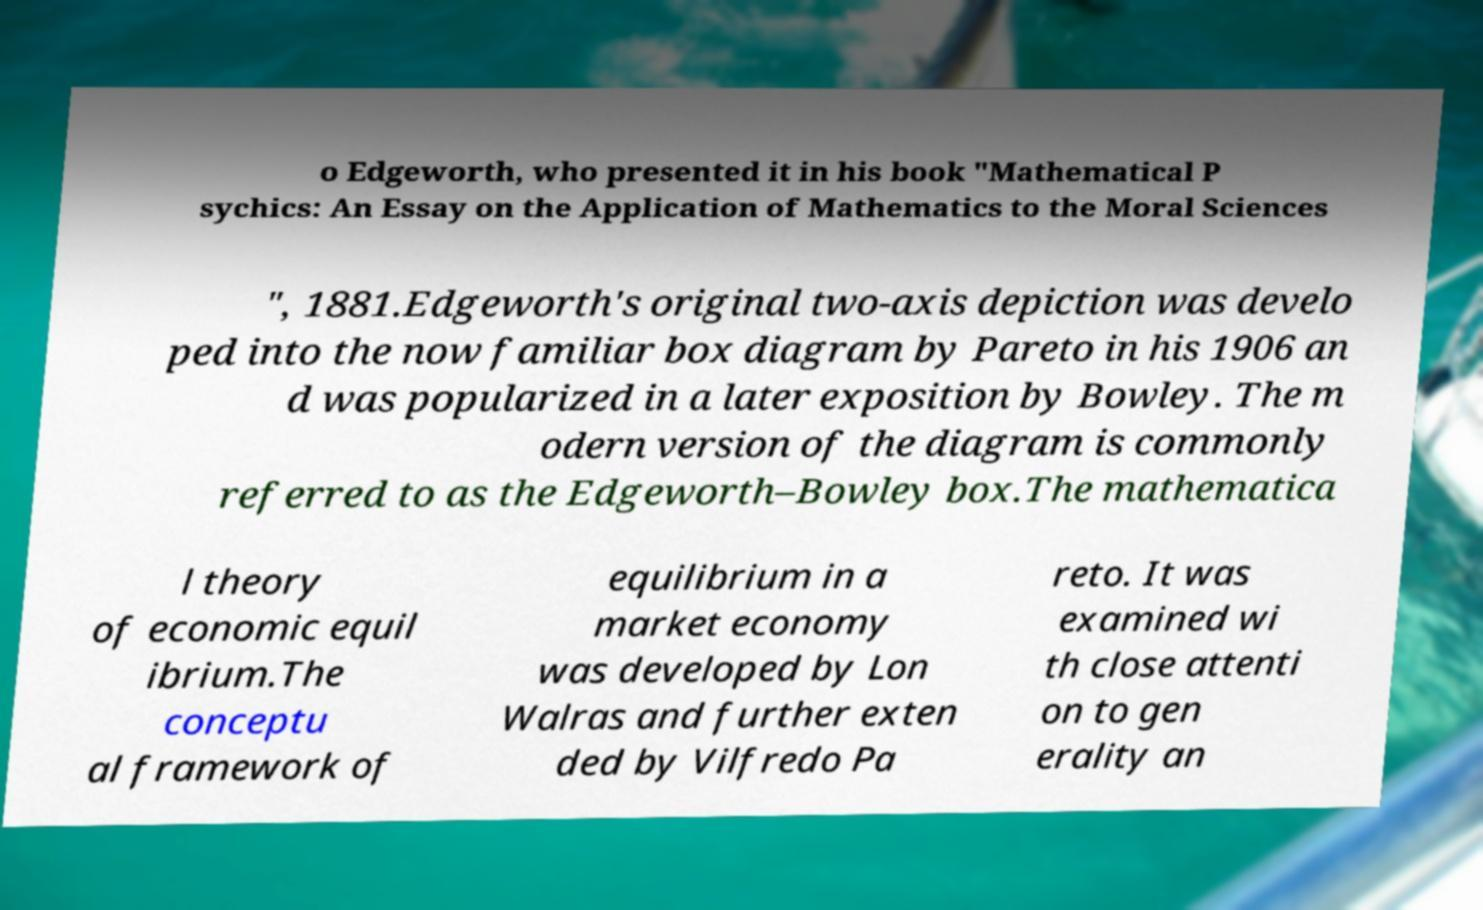There's text embedded in this image that I need extracted. Can you transcribe it verbatim? o Edgeworth, who presented it in his book "Mathematical P sychics: An Essay on the Application of Mathematics to the Moral Sciences ", 1881.Edgeworth's original two-axis depiction was develo ped into the now familiar box diagram by Pareto in his 1906 an d was popularized in a later exposition by Bowley. The m odern version of the diagram is commonly referred to as the Edgeworth–Bowley box.The mathematica l theory of economic equil ibrium.The conceptu al framework of equilibrium in a market economy was developed by Lon Walras and further exten ded by Vilfredo Pa reto. It was examined wi th close attenti on to gen erality an 